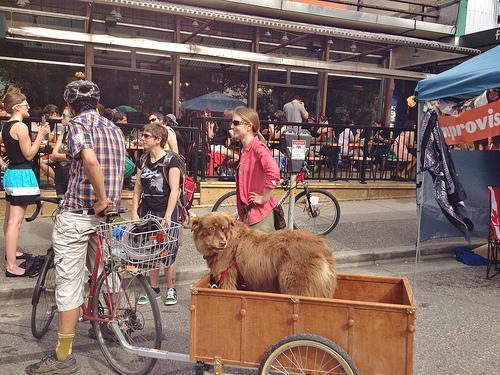How many animals are visible in the picture?
Give a very brief answer. 1. 